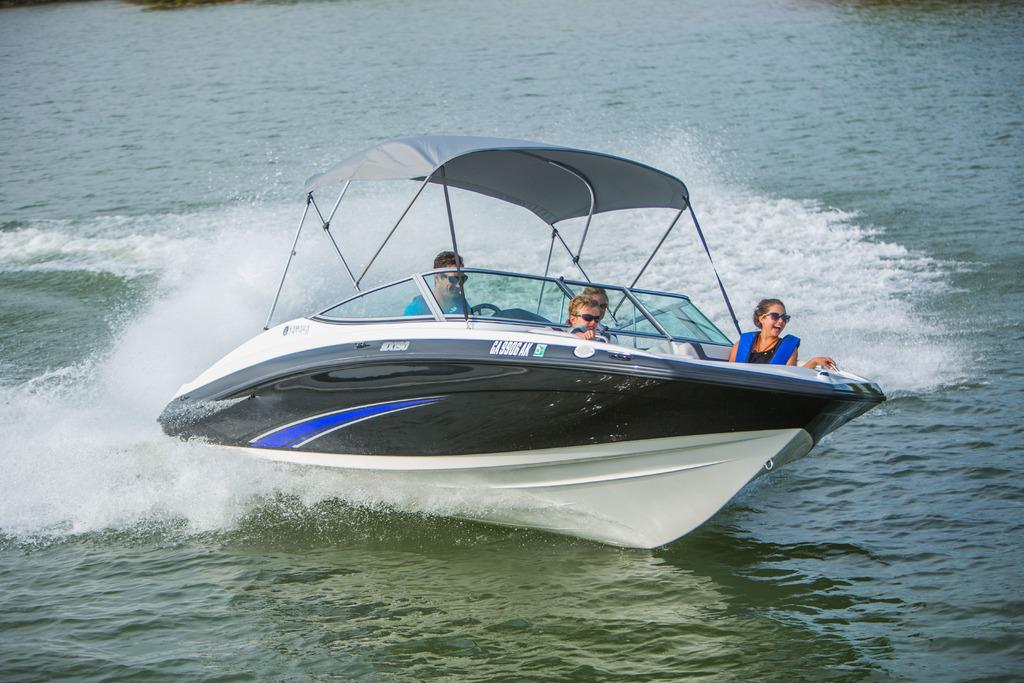What is the primary element visible in the image? There is water in the image. What is floating on the water in the image? There is a boat in the image. Who or what is inside the boat? There are people sitting in the boat. What type of ink is being used to write on the boat in the image? There is no ink or writing present on the boat in the image. What event is taking place in the image? The image does not depict a specific event; it simply shows a boat with people on the water. 